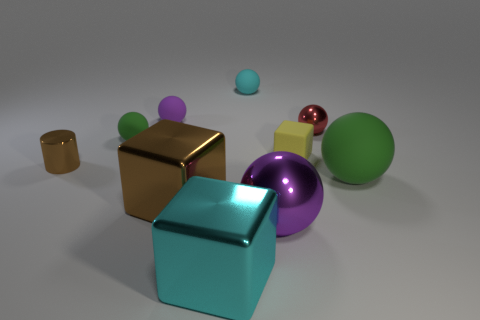How many matte objects are either tiny objects or brown cubes?
Give a very brief answer. 4. There is a object that is to the left of the large metal sphere and in front of the large brown shiny thing; what size is it?
Offer a very short reply. Large. Is there a big green rubber object that is in front of the large sphere on the right side of the purple metal ball?
Your answer should be very brief. No. How many yellow rubber blocks are on the left side of the small brown cylinder?
Make the answer very short. 0. There is a tiny metallic object that is the same shape as the big green object; what is its color?
Give a very brief answer. Red. Are the purple object behind the red sphere and the purple object in front of the large green ball made of the same material?
Provide a short and direct response. No. Is the color of the big rubber object the same as the tiny metallic thing that is right of the big purple thing?
Ensure brevity in your answer.  No. What shape is the matte thing that is both on the right side of the tiny cyan rubber thing and behind the small brown cylinder?
Your answer should be compact. Cube. How many purple shiny cubes are there?
Keep it short and to the point. 0. What is the shape of the small object that is the same color as the big metallic sphere?
Give a very brief answer. Sphere. 